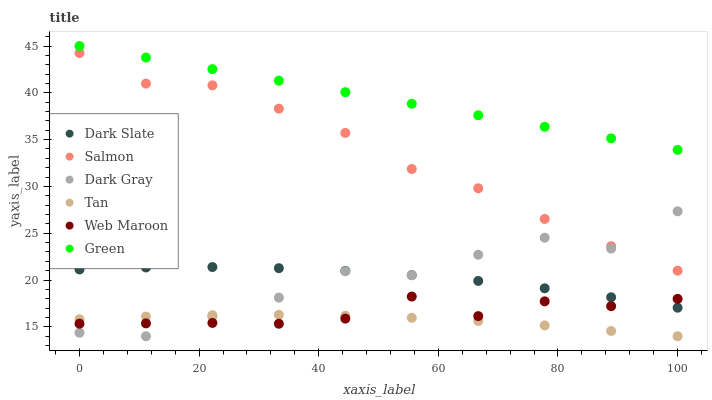Does Tan have the minimum area under the curve?
Answer yes or no. Yes. Does Green have the maximum area under the curve?
Answer yes or no. Yes. Does Salmon have the minimum area under the curve?
Answer yes or no. No. Does Salmon have the maximum area under the curve?
Answer yes or no. No. Is Green the smoothest?
Answer yes or no. Yes. Is Dark Gray the roughest?
Answer yes or no. Yes. Is Salmon the smoothest?
Answer yes or no. No. Is Salmon the roughest?
Answer yes or no. No. Does Dark Gray have the lowest value?
Answer yes or no. Yes. Does Salmon have the lowest value?
Answer yes or no. No. Does Green have the highest value?
Answer yes or no. Yes. Does Salmon have the highest value?
Answer yes or no. No. Is Tan less than Salmon?
Answer yes or no. Yes. Is Green greater than Salmon?
Answer yes or no. Yes. Does Dark Slate intersect Web Maroon?
Answer yes or no. Yes. Is Dark Slate less than Web Maroon?
Answer yes or no. No. Is Dark Slate greater than Web Maroon?
Answer yes or no. No. Does Tan intersect Salmon?
Answer yes or no. No. 